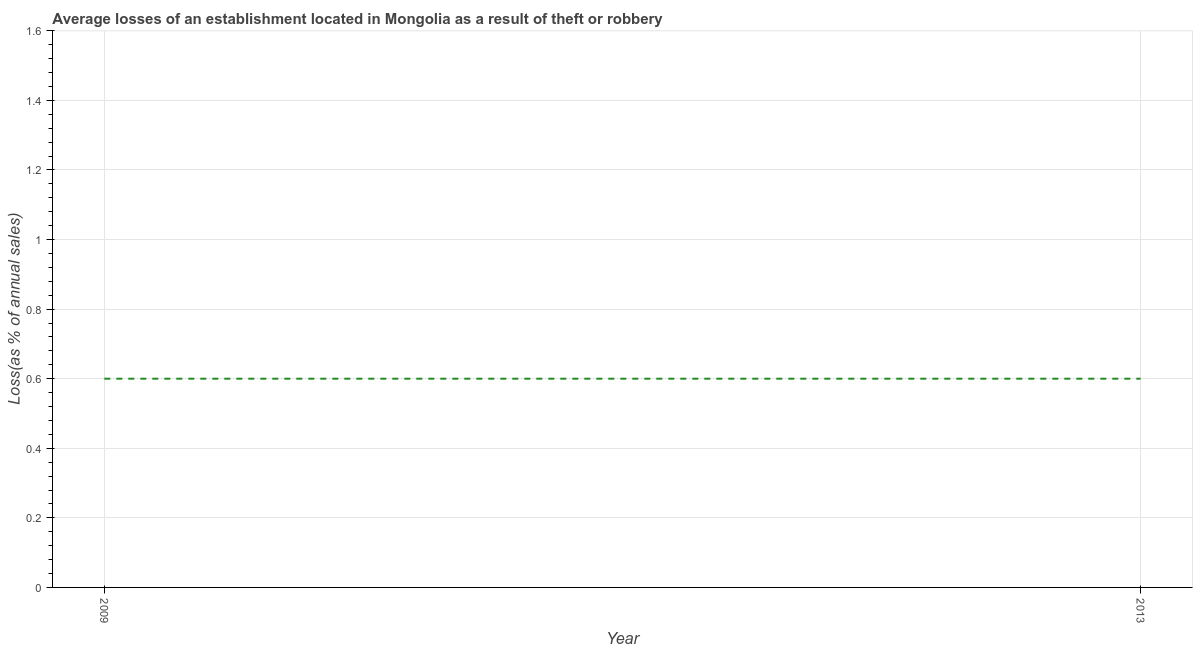Across all years, what is the minimum losses due to theft?
Keep it short and to the point. 0.6. In which year was the losses due to theft minimum?
Your response must be concise. 2009. What is the difference between the losses due to theft in 2009 and 2013?
Provide a short and direct response. 0. What is the ratio of the losses due to theft in 2009 to that in 2013?
Give a very brief answer. 1. In how many years, is the losses due to theft greater than the average losses due to theft taken over all years?
Your response must be concise. 0. Does the losses due to theft monotonically increase over the years?
Give a very brief answer. No. How many lines are there?
Keep it short and to the point. 1. What is the difference between two consecutive major ticks on the Y-axis?
Your answer should be compact. 0.2. Does the graph contain grids?
Your response must be concise. Yes. What is the title of the graph?
Your response must be concise. Average losses of an establishment located in Mongolia as a result of theft or robbery. What is the label or title of the X-axis?
Give a very brief answer. Year. What is the label or title of the Y-axis?
Provide a succinct answer. Loss(as % of annual sales). What is the Loss(as % of annual sales) in 2009?
Make the answer very short. 0.6. What is the Loss(as % of annual sales) in 2013?
Provide a short and direct response. 0.6. What is the difference between the Loss(as % of annual sales) in 2009 and 2013?
Make the answer very short. 0. What is the ratio of the Loss(as % of annual sales) in 2009 to that in 2013?
Provide a succinct answer. 1. 